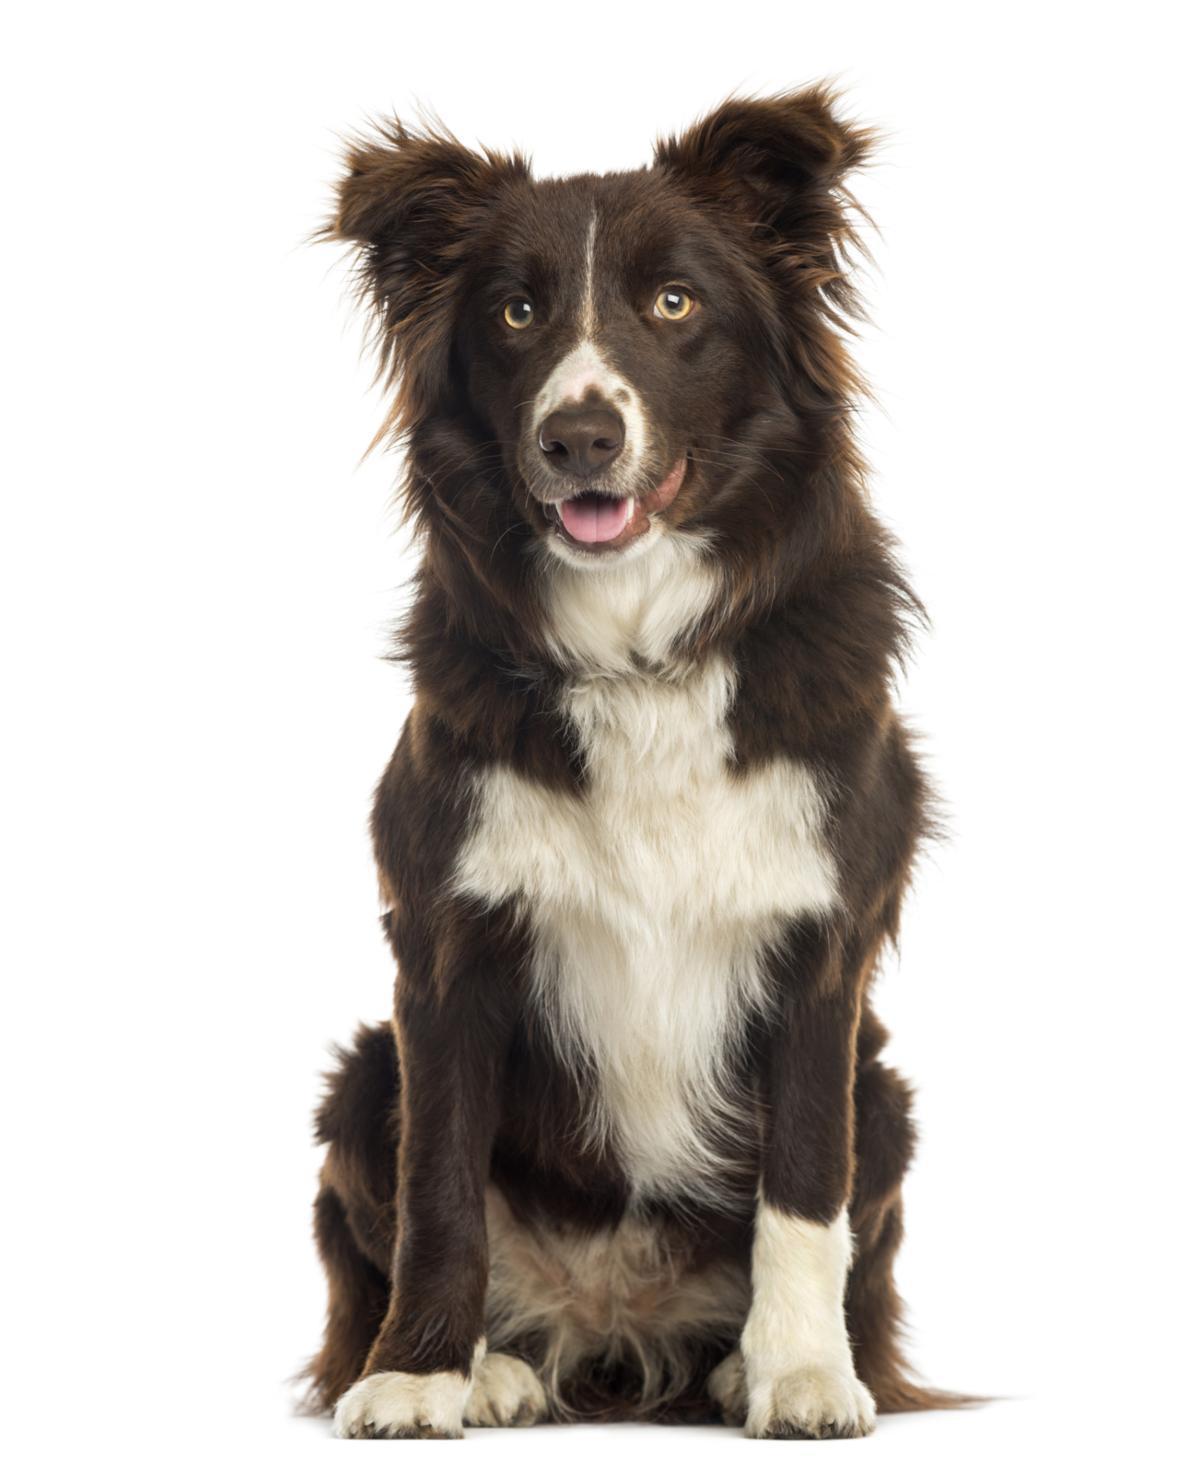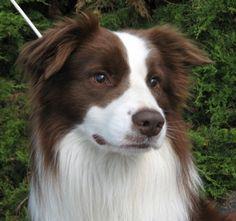The first image is the image on the left, the second image is the image on the right. For the images shown, is this caption "One dog is black with white on its legs and chest." true? Answer yes or no. Yes. The first image is the image on the left, the second image is the image on the right. Considering the images on both sides, is "At least one dog has its mouth open." valid? Answer yes or no. Yes. 